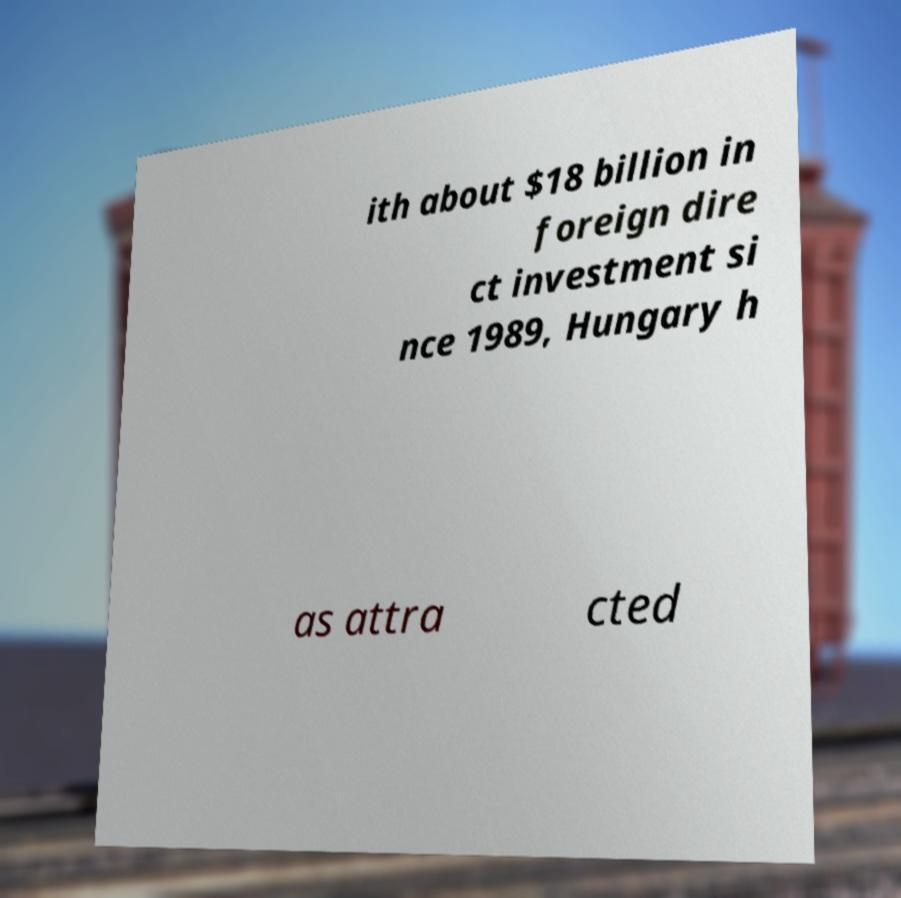Please read and relay the text visible in this image. What does it say? ith about $18 billion in foreign dire ct investment si nce 1989, Hungary h as attra cted 